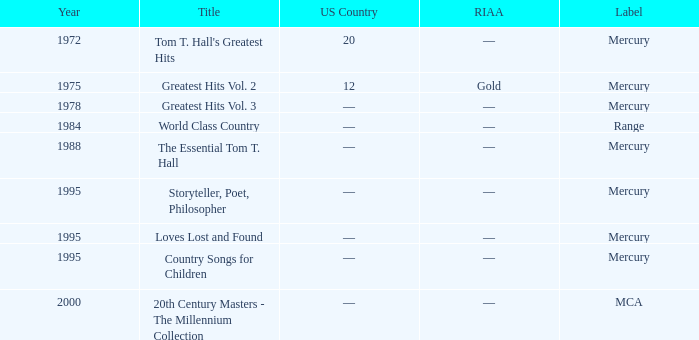What title was given to the album post-1978? Range, Mercury, Mercury, Mercury, Mercury, MCA. 